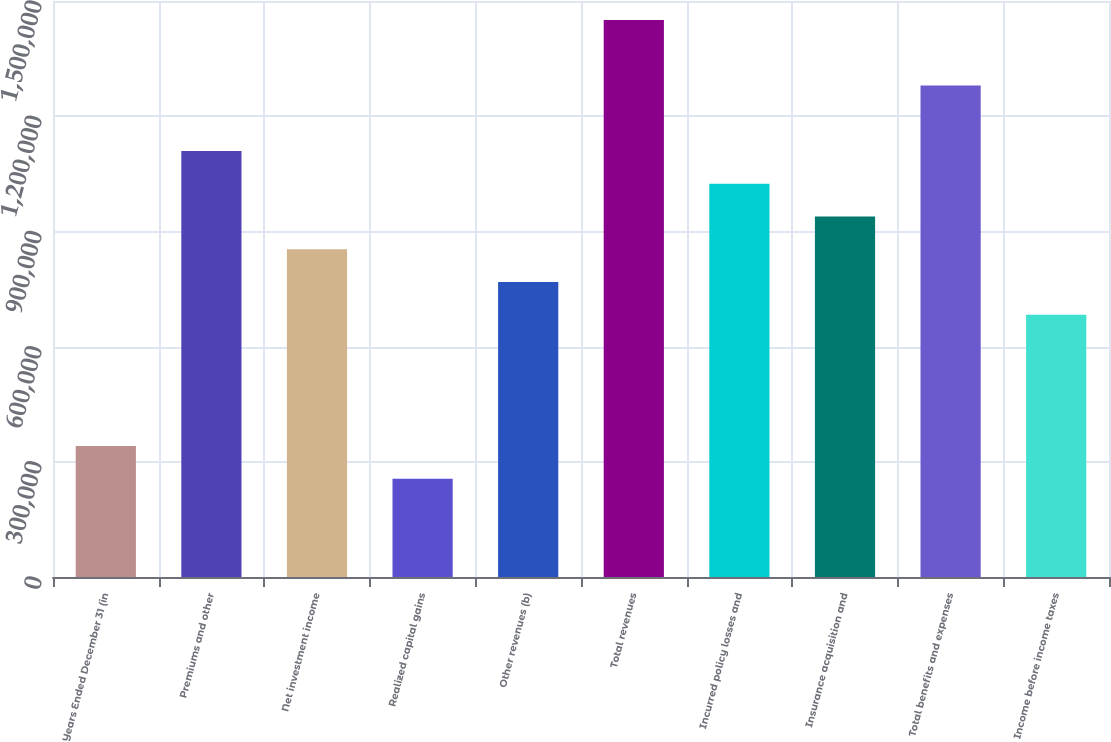Convert chart to OTSL. <chart><loc_0><loc_0><loc_500><loc_500><bar_chart><fcel>Years Ended December 31 (in<fcel>Premiums and other<fcel>Net investment income<fcel>Realized capital gains<fcel>Other revenues (b)<fcel>Total revenues<fcel>Incurred policy losses and<fcel>Insurance acquisition and<fcel>Total benefits and expenses<fcel>Income before income taxes<nl><fcel>341348<fcel>1.10938e+06<fcel>853370<fcel>256011<fcel>768033<fcel>1.45073e+06<fcel>1.02404e+06<fcel>938707<fcel>1.28005e+06<fcel>682696<nl></chart> 